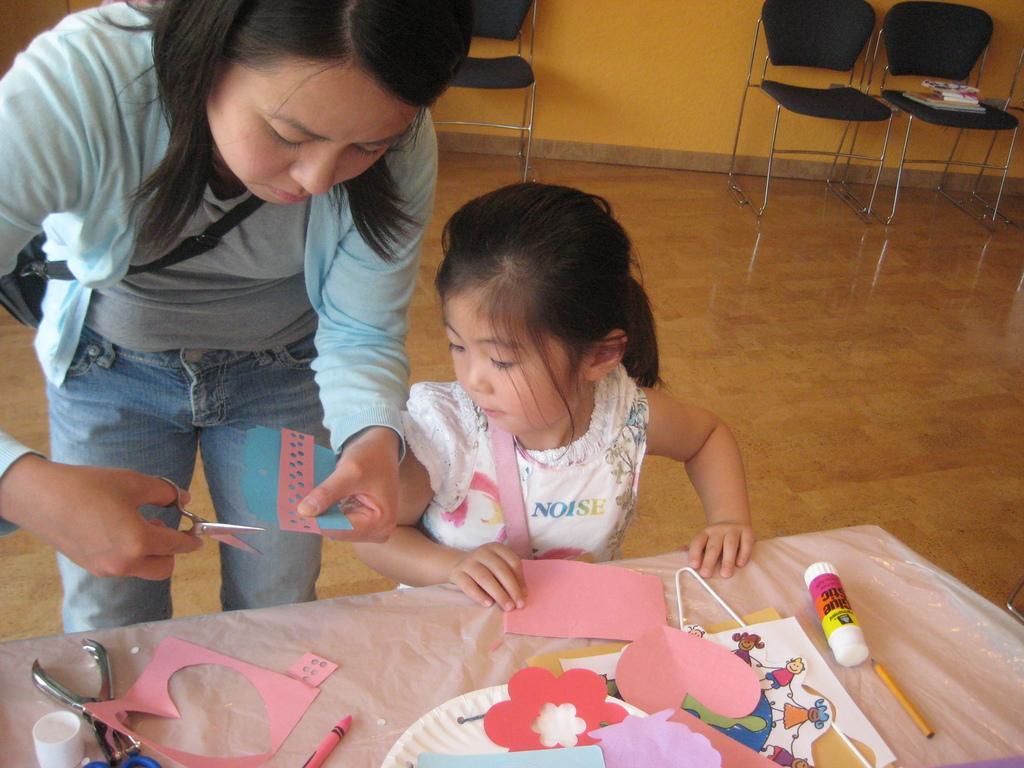How would you summarize this image in a sentence or two? In this image we can see a lady wearing bag and she is holding scissors and paper. Also there is a child. And there is a table. On the table there is gum, pencil, papers, crayon and few other things. In the back there are chairs. On the chair there are books. Also there is a wall. 